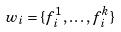<formula> <loc_0><loc_0><loc_500><loc_500>w _ { i } = \{ f _ { i } ^ { 1 } , \dots , f _ { i } ^ { k } \}</formula> 